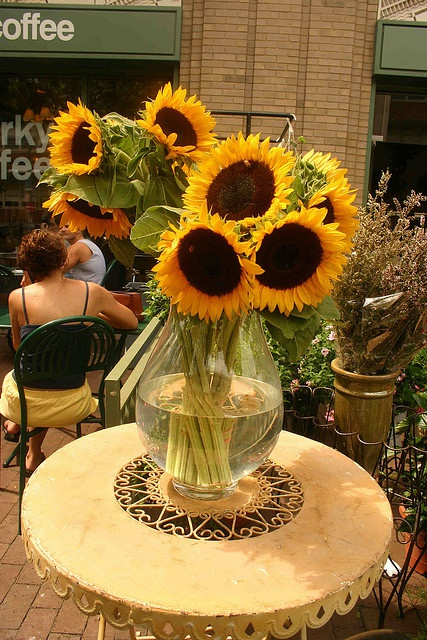Describe the objects in this image and their specific colors. I can see dining table in olive, khaki, tan, and maroon tones, vase in olive and tan tones, potted plant in olive, black, and maroon tones, people in olive, black, tan, and maroon tones, and chair in olive, black, and maroon tones in this image. 